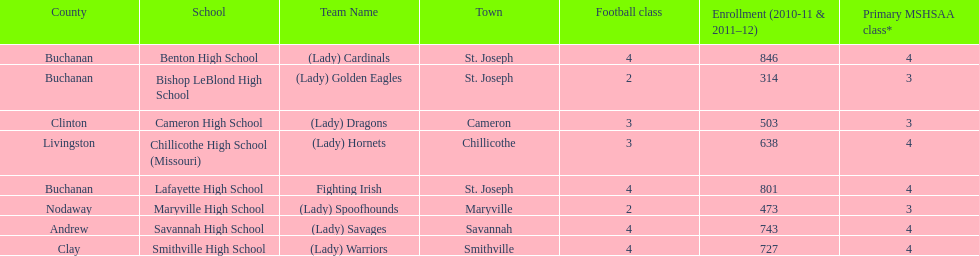What school has 3 football classes but only has 638 student enrollment? Chillicothe High School (Missouri). 